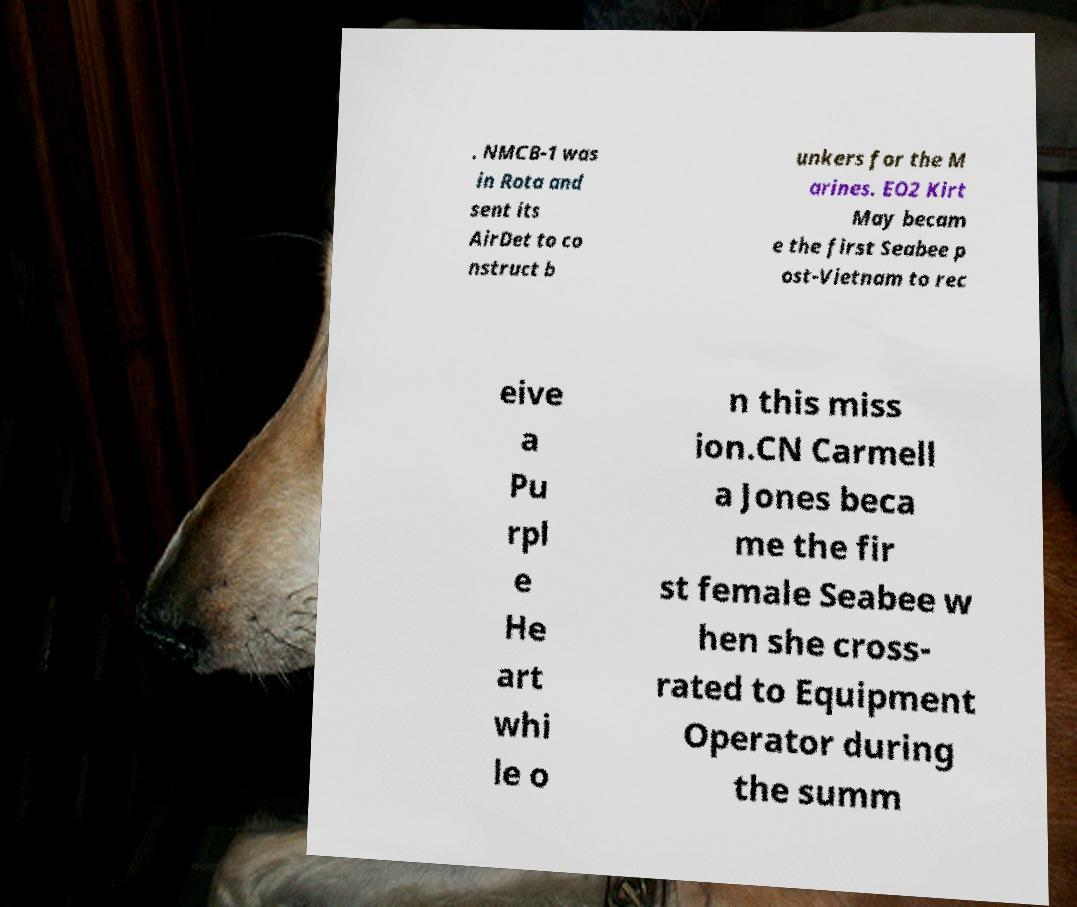Please read and relay the text visible in this image. What does it say? . NMCB-1 was in Rota and sent its AirDet to co nstruct b unkers for the M arines. EO2 Kirt May becam e the first Seabee p ost-Vietnam to rec eive a Pu rpl e He art whi le o n this miss ion.CN Carmell a Jones beca me the fir st female Seabee w hen she cross- rated to Equipment Operator during the summ 